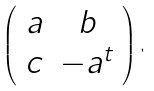Convert formula to latex. <formula><loc_0><loc_0><loc_500><loc_500>\left ( \begin{array} { c c } a & b \\ c & - a ^ { t } \end{array} \right ) ,</formula> 